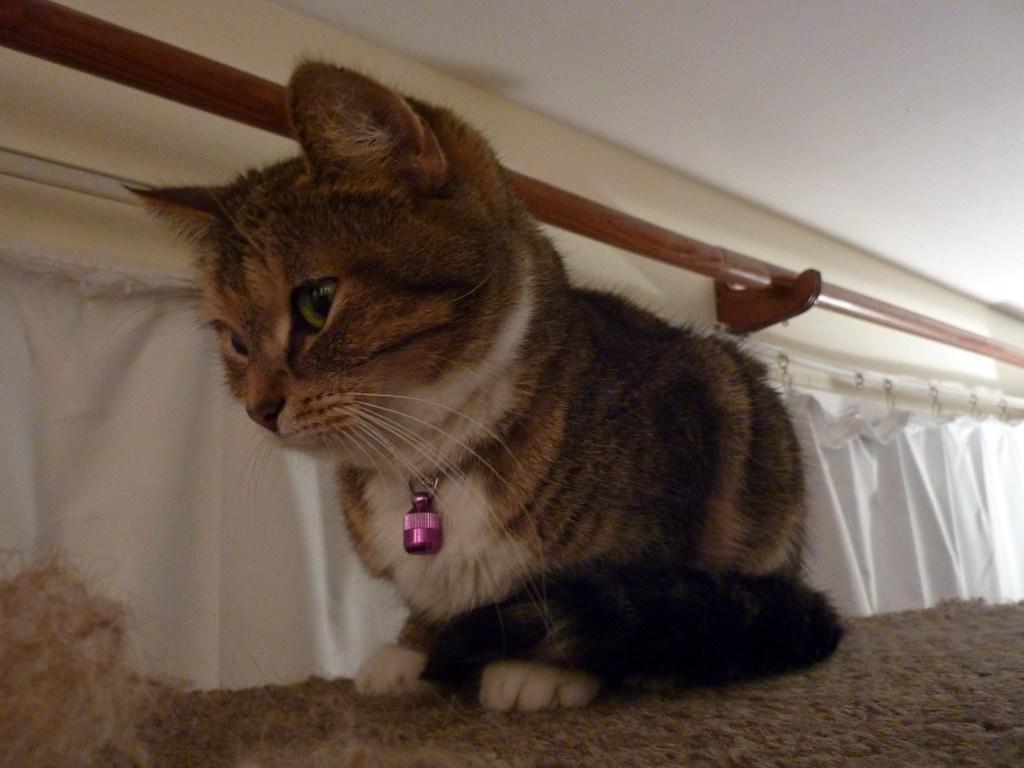In one or two sentences, can you explain what this image depicts? As we can see in the image there is a cat, white color cloth and wall. 